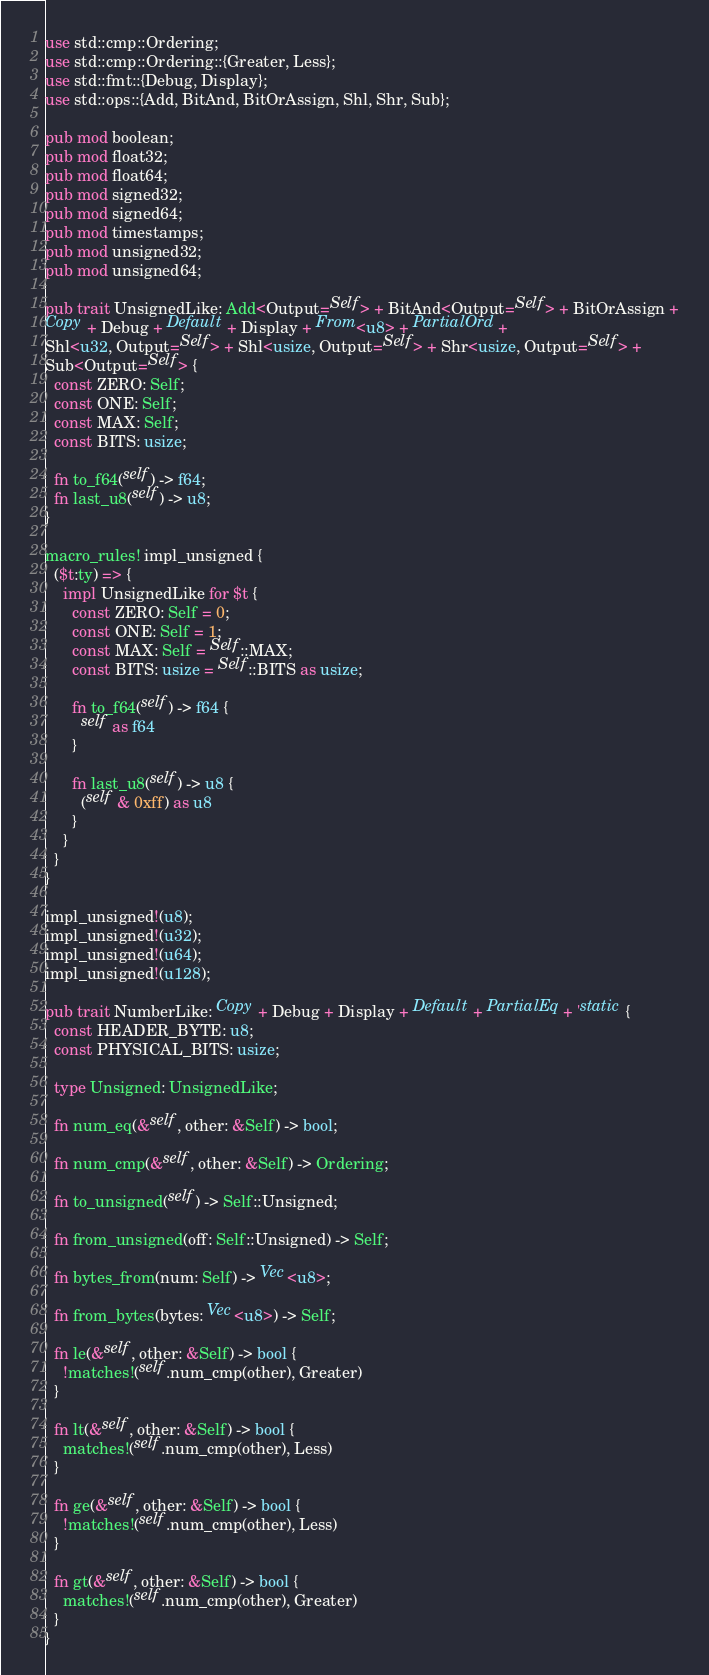<code> <loc_0><loc_0><loc_500><loc_500><_Rust_>use std::cmp::Ordering;
use std::cmp::Ordering::{Greater, Less};
use std::fmt::{Debug, Display};
use std::ops::{Add, BitAnd, BitOrAssign, Shl, Shr, Sub};

pub mod boolean;
pub mod float32;
pub mod float64;
pub mod signed32;
pub mod signed64;
pub mod timestamps;
pub mod unsigned32;
pub mod unsigned64;

pub trait UnsignedLike: Add<Output=Self> + BitAnd<Output=Self> + BitOrAssign +
Copy + Debug + Default + Display + From<u8> + PartialOrd +
Shl<u32, Output=Self> + Shl<usize, Output=Self> + Shr<usize, Output=Self> +
Sub<Output=Self> {
  const ZERO: Self;
  const ONE: Self;
  const MAX: Self;
  const BITS: usize;

  fn to_f64(self) -> f64;
  fn last_u8(self) -> u8;
}

macro_rules! impl_unsigned {
  ($t:ty) => {
    impl UnsignedLike for $t {
      const ZERO: Self = 0;
      const ONE: Self = 1;
      const MAX: Self = Self::MAX;
      const BITS: usize = Self::BITS as usize;

      fn to_f64(self) -> f64 {
        self as f64
      }

      fn last_u8(self) -> u8 {
        (self & 0xff) as u8
      }
    }
  }
}

impl_unsigned!(u8);
impl_unsigned!(u32);
impl_unsigned!(u64);
impl_unsigned!(u128);

pub trait NumberLike: Copy + Debug + Display + Default + PartialEq + 'static {
  const HEADER_BYTE: u8;
  const PHYSICAL_BITS: usize;

  type Unsigned: UnsignedLike;

  fn num_eq(&self, other: &Self) -> bool;

  fn num_cmp(&self, other: &Self) -> Ordering;

  fn to_unsigned(self) -> Self::Unsigned;

  fn from_unsigned(off: Self::Unsigned) -> Self;

  fn bytes_from(num: Self) -> Vec<u8>;

  fn from_bytes(bytes: Vec<u8>) -> Self;

  fn le(&self, other: &Self) -> bool {
    !matches!(self.num_cmp(other), Greater)
  }

  fn lt(&self, other: &Self) -> bool {
    matches!(self.num_cmp(other), Less)
  }

  fn ge(&self, other: &Self) -> bool {
    !matches!(self.num_cmp(other), Less)
  }

  fn gt(&self, other: &Self) -> bool {
    matches!(self.num_cmp(other), Greater)
  }
}
</code> 